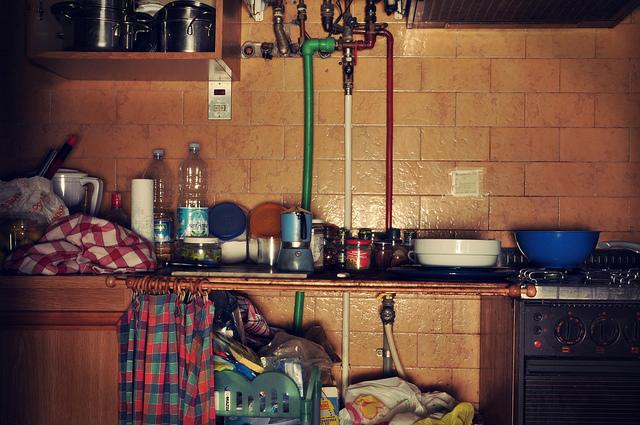When the pipes need to be worked on plumbers will be blocked from reaching it by what? trash 